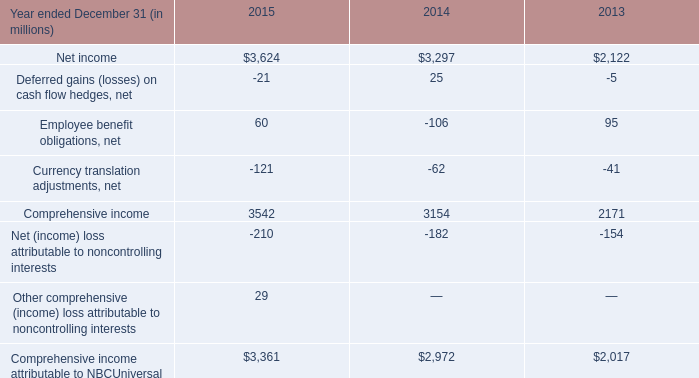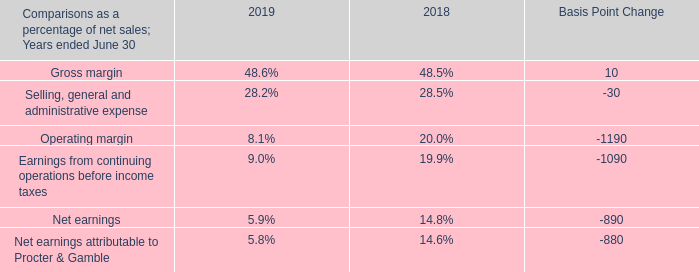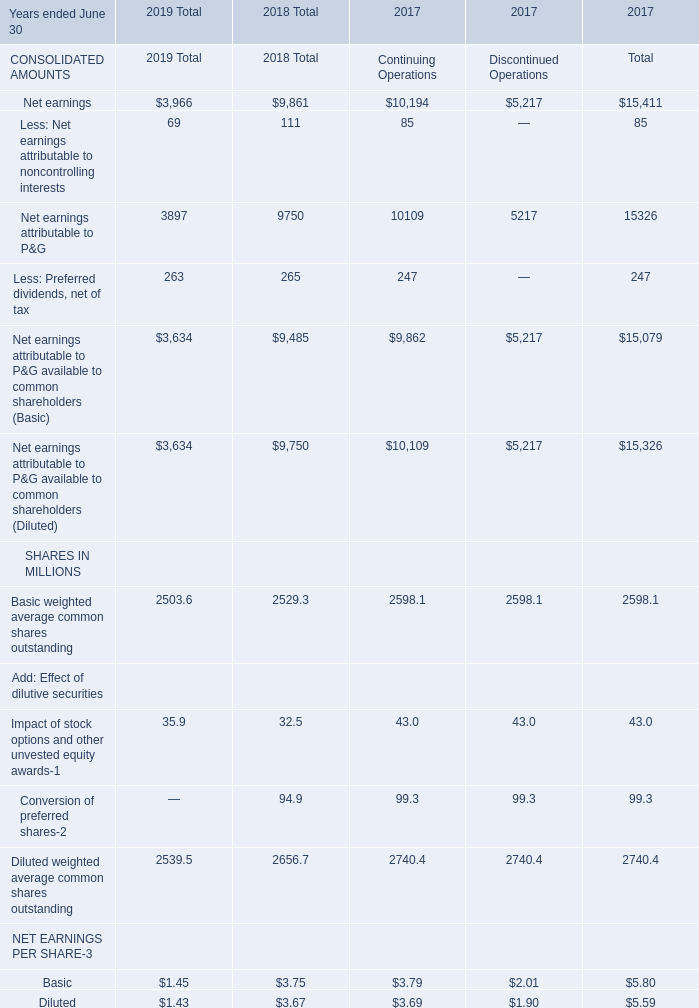What is the total amount of Comprehensive income of 2014, Net earnings of 2017 Discontinued Operations, and Net income of 2013 ? 
Computations: ((3154.0 + 5217.0) + 2122.0)
Answer: 10493.0. 